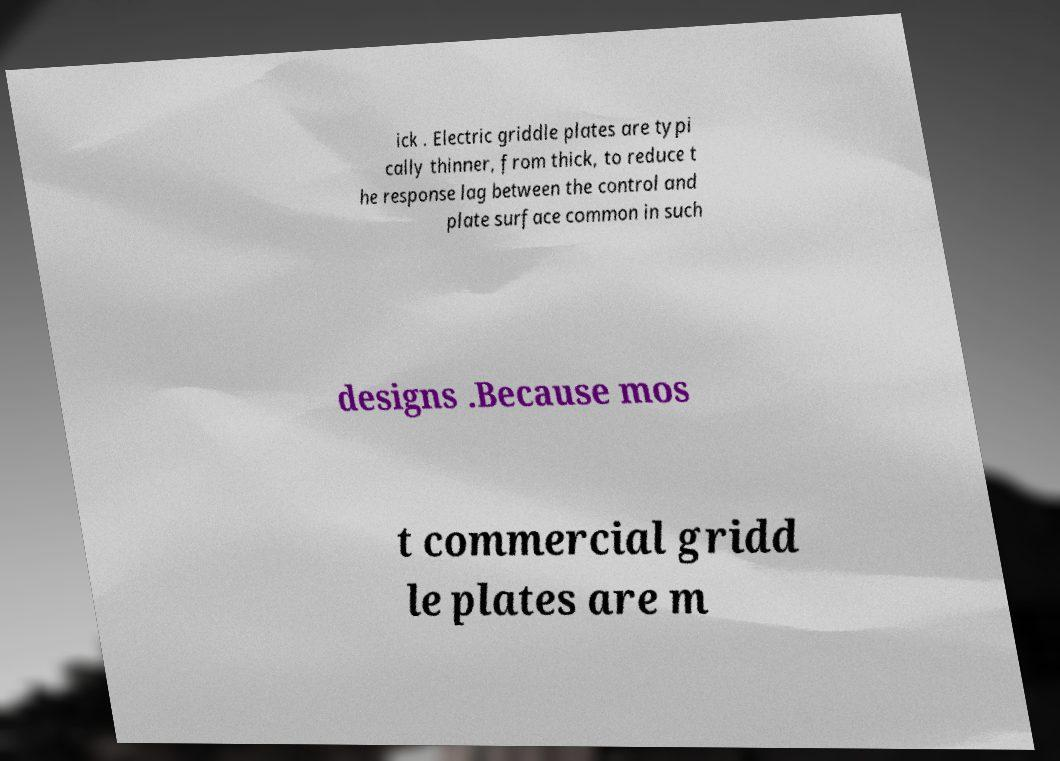I need the written content from this picture converted into text. Can you do that? ick . Electric griddle plates are typi cally thinner, from thick, to reduce t he response lag between the control and plate surface common in such designs .Because mos t commercial gridd le plates are m 